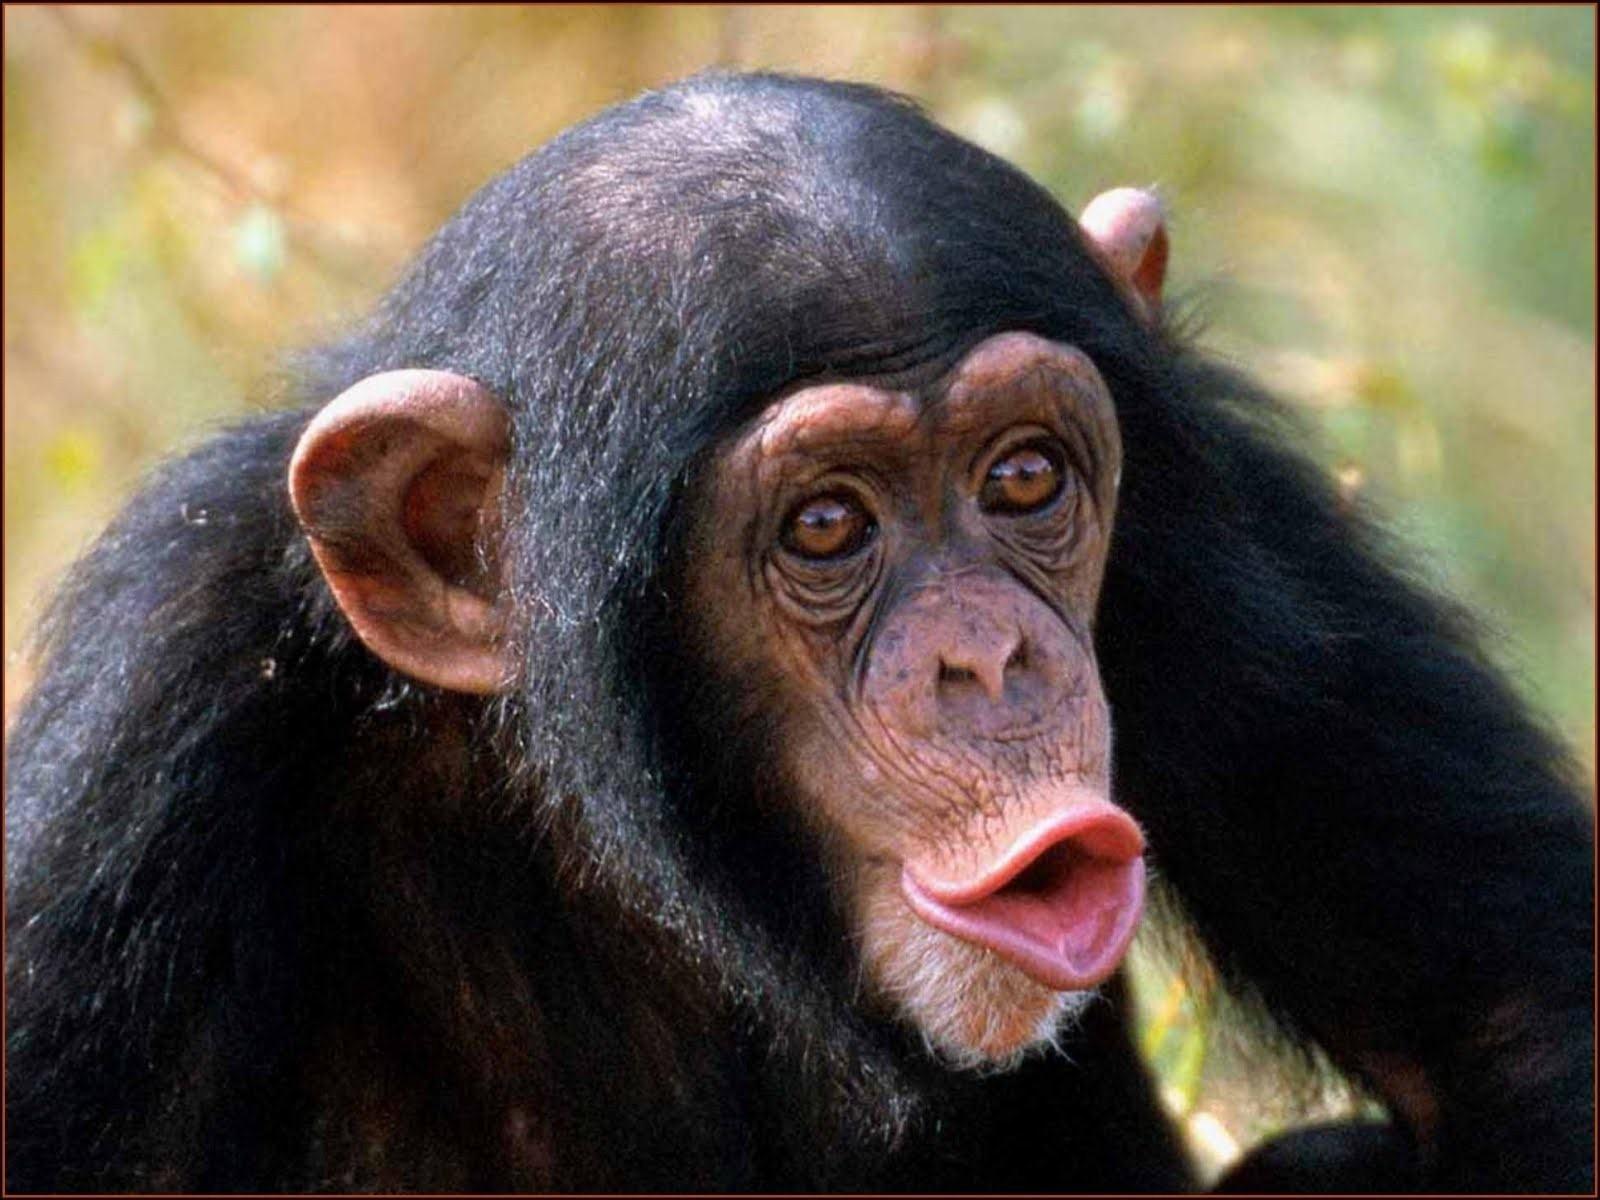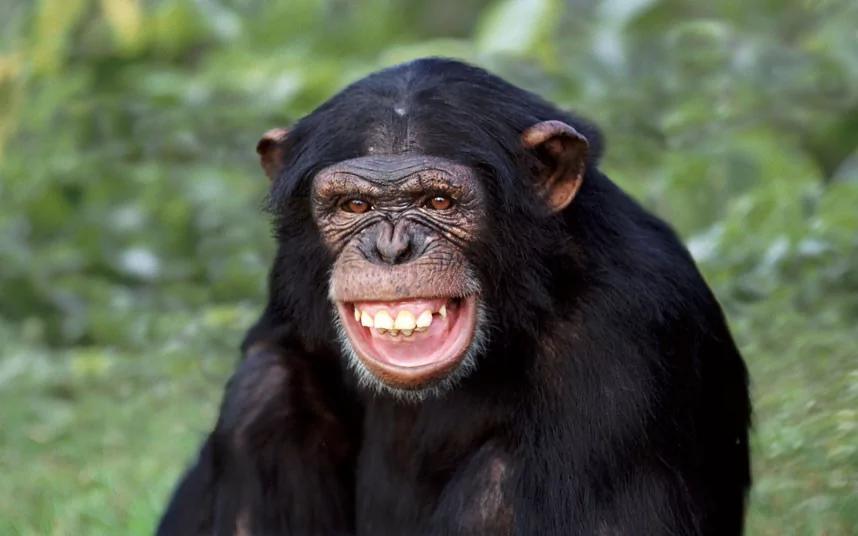The first image is the image on the left, the second image is the image on the right. Examine the images to the left and right. Is the description "The chimp in the right image is showing his teeth." accurate? Answer yes or no. Yes. 